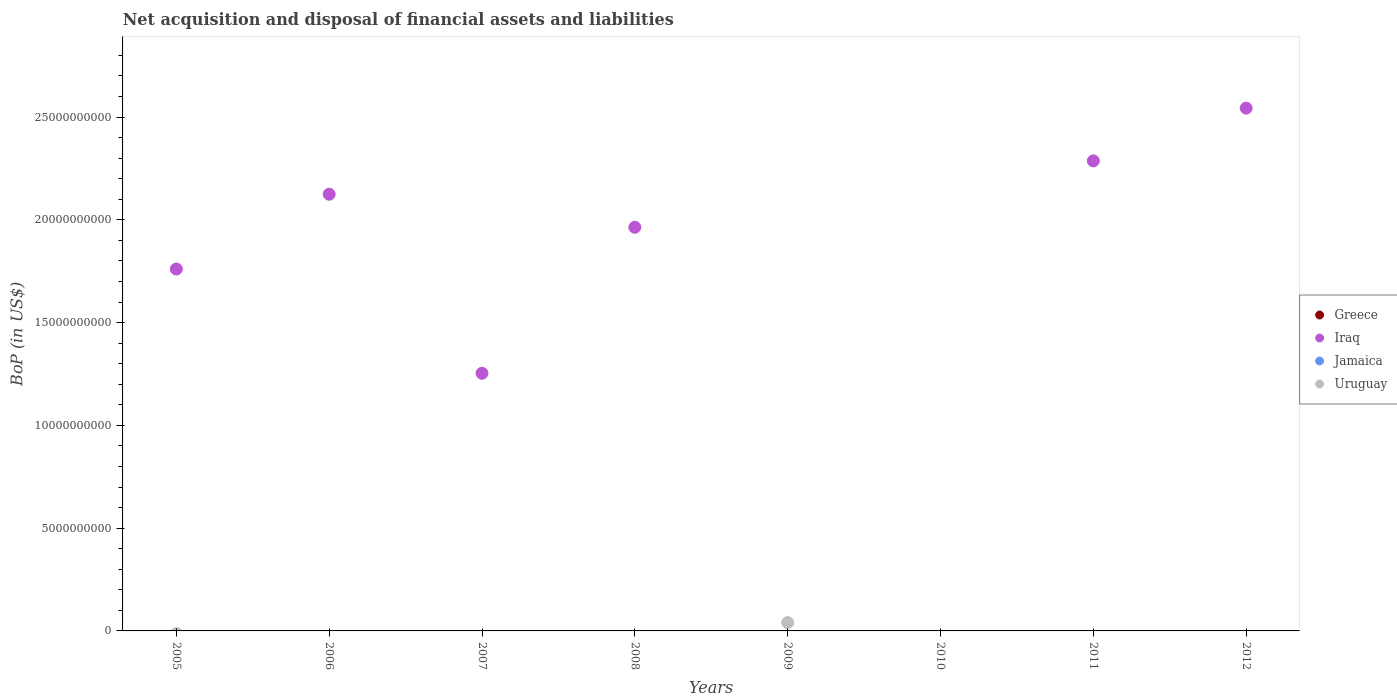How many different coloured dotlines are there?
Offer a very short reply. 2. Is the number of dotlines equal to the number of legend labels?
Offer a terse response. No. What is the Balance of Payments in Iraq in 2012?
Your response must be concise. 2.54e+1. Across all years, what is the maximum Balance of Payments in Iraq?
Offer a terse response. 2.54e+1. Across all years, what is the minimum Balance of Payments in Uruguay?
Your answer should be compact. 0. In which year was the Balance of Payments in Uruguay maximum?
Provide a succinct answer. 2009. What is the total Balance of Payments in Uruguay in the graph?
Your answer should be very brief. 4.04e+08. What is the difference between the Balance of Payments in Iraq in 2007 and that in 2008?
Ensure brevity in your answer.  -7.10e+09. What is the average Balance of Payments in Greece per year?
Your response must be concise. 0. In how many years, is the Balance of Payments in Jamaica greater than 24000000000 US$?
Offer a terse response. 0. What is the ratio of the Balance of Payments in Iraq in 2006 to that in 2008?
Provide a short and direct response. 1.08. What is the difference between the highest and the second highest Balance of Payments in Iraq?
Keep it short and to the point. 2.56e+09. What is the difference between the highest and the lowest Balance of Payments in Iraq?
Give a very brief answer. 2.54e+1. Is the sum of the Balance of Payments in Iraq in 2011 and 2012 greater than the maximum Balance of Payments in Uruguay across all years?
Give a very brief answer. Yes. Is it the case that in every year, the sum of the Balance of Payments in Jamaica and Balance of Payments in Iraq  is greater than the sum of Balance of Payments in Greece and Balance of Payments in Uruguay?
Provide a succinct answer. No. Is it the case that in every year, the sum of the Balance of Payments in Iraq and Balance of Payments in Greece  is greater than the Balance of Payments in Uruguay?
Provide a short and direct response. No. Does the Balance of Payments in Greece monotonically increase over the years?
Offer a very short reply. No. How many dotlines are there?
Offer a very short reply. 2. How many years are there in the graph?
Provide a succinct answer. 8. What is the difference between two consecutive major ticks on the Y-axis?
Keep it short and to the point. 5.00e+09. Does the graph contain any zero values?
Provide a short and direct response. Yes. Does the graph contain grids?
Ensure brevity in your answer.  No. Where does the legend appear in the graph?
Make the answer very short. Center right. How many legend labels are there?
Provide a short and direct response. 4. How are the legend labels stacked?
Your answer should be very brief. Vertical. What is the title of the graph?
Give a very brief answer. Net acquisition and disposal of financial assets and liabilities. Does "Somalia" appear as one of the legend labels in the graph?
Keep it short and to the point. No. What is the label or title of the Y-axis?
Offer a terse response. BoP (in US$). What is the BoP (in US$) of Iraq in 2005?
Your answer should be compact. 1.76e+1. What is the BoP (in US$) in Uruguay in 2005?
Offer a terse response. 0. What is the BoP (in US$) in Iraq in 2006?
Offer a terse response. 2.12e+1. What is the BoP (in US$) of Jamaica in 2006?
Your answer should be very brief. 0. What is the BoP (in US$) in Uruguay in 2006?
Make the answer very short. 0. What is the BoP (in US$) of Greece in 2007?
Give a very brief answer. 0. What is the BoP (in US$) of Iraq in 2007?
Offer a very short reply. 1.25e+1. What is the BoP (in US$) in Jamaica in 2007?
Offer a terse response. 0. What is the BoP (in US$) of Uruguay in 2007?
Offer a terse response. 0. What is the BoP (in US$) of Iraq in 2008?
Offer a very short reply. 1.96e+1. What is the BoP (in US$) of Iraq in 2009?
Your answer should be very brief. 0. What is the BoP (in US$) of Jamaica in 2009?
Your answer should be very brief. 0. What is the BoP (in US$) in Uruguay in 2009?
Provide a succinct answer. 4.04e+08. What is the BoP (in US$) in Uruguay in 2010?
Your answer should be compact. 0. What is the BoP (in US$) in Iraq in 2011?
Offer a very short reply. 2.29e+1. What is the BoP (in US$) of Jamaica in 2011?
Your answer should be compact. 0. What is the BoP (in US$) in Iraq in 2012?
Your answer should be compact. 2.54e+1. What is the BoP (in US$) in Uruguay in 2012?
Your answer should be very brief. 0. Across all years, what is the maximum BoP (in US$) in Iraq?
Your answer should be very brief. 2.54e+1. Across all years, what is the maximum BoP (in US$) of Uruguay?
Keep it short and to the point. 4.04e+08. Across all years, what is the minimum BoP (in US$) of Uruguay?
Provide a short and direct response. 0. What is the total BoP (in US$) of Greece in the graph?
Make the answer very short. 0. What is the total BoP (in US$) in Iraq in the graph?
Your answer should be compact. 1.19e+11. What is the total BoP (in US$) of Jamaica in the graph?
Offer a very short reply. 0. What is the total BoP (in US$) of Uruguay in the graph?
Provide a short and direct response. 4.04e+08. What is the difference between the BoP (in US$) of Iraq in 2005 and that in 2006?
Ensure brevity in your answer.  -3.64e+09. What is the difference between the BoP (in US$) of Iraq in 2005 and that in 2007?
Give a very brief answer. 5.07e+09. What is the difference between the BoP (in US$) of Iraq in 2005 and that in 2008?
Provide a short and direct response. -2.03e+09. What is the difference between the BoP (in US$) of Iraq in 2005 and that in 2011?
Give a very brief answer. -5.26e+09. What is the difference between the BoP (in US$) in Iraq in 2005 and that in 2012?
Offer a very short reply. -7.83e+09. What is the difference between the BoP (in US$) of Iraq in 2006 and that in 2007?
Give a very brief answer. 8.71e+09. What is the difference between the BoP (in US$) of Iraq in 2006 and that in 2008?
Provide a succinct answer. 1.61e+09. What is the difference between the BoP (in US$) in Iraq in 2006 and that in 2011?
Provide a succinct answer. -1.62e+09. What is the difference between the BoP (in US$) in Iraq in 2006 and that in 2012?
Provide a succinct answer. -4.19e+09. What is the difference between the BoP (in US$) of Iraq in 2007 and that in 2008?
Your response must be concise. -7.10e+09. What is the difference between the BoP (in US$) of Iraq in 2007 and that in 2011?
Offer a terse response. -1.03e+1. What is the difference between the BoP (in US$) of Iraq in 2007 and that in 2012?
Your response must be concise. -1.29e+1. What is the difference between the BoP (in US$) of Iraq in 2008 and that in 2011?
Offer a terse response. -3.23e+09. What is the difference between the BoP (in US$) of Iraq in 2008 and that in 2012?
Provide a short and direct response. -5.80e+09. What is the difference between the BoP (in US$) of Iraq in 2011 and that in 2012?
Your answer should be very brief. -2.56e+09. What is the difference between the BoP (in US$) in Iraq in 2005 and the BoP (in US$) in Uruguay in 2009?
Ensure brevity in your answer.  1.72e+1. What is the difference between the BoP (in US$) in Iraq in 2006 and the BoP (in US$) in Uruguay in 2009?
Your answer should be very brief. 2.08e+1. What is the difference between the BoP (in US$) in Iraq in 2007 and the BoP (in US$) in Uruguay in 2009?
Offer a terse response. 1.21e+1. What is the difference between the BoP (in US$) in Iraq in 2008 and the BoP (in US$) in Uruguay in 2009?
Give a very brief answer. 1.92e+1. What is the average BoP (in US$) in Iraq per year?
Offer a very short reply. 1.49e+1. What is the average BoP (in US$) in Jamaica per year?
Your answer should be very brief. 0. What is the average BoP (in US$) of Uruguay per year?
Offer a very short reply. 5.06e+07. What is the ratio of the BoP (in US$) in Iraq in 2005 to that in 2006?
Give a very brief answer. 0.83. What is the ratio of the BoP (in US$) of Iraq in 2005 to that in 2007?
Keep it short and to the point. 1.4. What is the ratio of the BoP (in US$) of Iraq in 2005 to that in 2008?
Keep it short and to the point. 0.9. What is the ratio of the BoP (in US$) of Iraq in 2005 to that in 2011?
Your response must be concise. 0.77. What is the ratio of the BoP (in US$) of Iraq in 2005 to that in 2012?
Your answer should be compact. 0.69. What is the ratio of the BoP (in US$) of Iraq in 2006 to that in 2007?
Provide a short and direct response. 1.69. What is the ratio of the BoP (in US$) of Iraq in 2006 to that in 2008?
Offer a very short reply. 1.08. What is the ratio of the BoP (in US$) in Iraq in 2006 to that in 2011?
Your answer should be compact. 0.93. What is the ratio of the BoP (in US$) in Iraq in 2006 to that in 2012?
Your answer should be compact. 0.84. What is the ratio of the BoP (in US$) in Iraq in 2007 to that in 2008?
Offer a terse response. 0.64. What is the ratio of the BoP (in US$) of Iraq in 2007 to that in 2011?
Keep it short and to the point. 0.55. What is the ratio of the BoP (in US$) in Iraq in 2007 to that in 2012?
Make the answer very short. 0.49. What is the ratio of the BoP (in US$) of Iraq in 2008 to that in 2011?
Give a very brief answer. 0.86. What is the ratio of the BoP (in US$) of Iraq in 2008 to that in 2012?
Your answer should be very brief. 0.77. What is the ratio of the BoP (in US$) of Iraq in 2011 to that in 2012?
Your response must be concise. 0.9. What is the difference between the highest and the second highest BoP (in US$) of Iraq?
Give a very brief answer. 2.56e+09. What is the difference between the highest and the lowest BoP (in US$) of Iraq?
Keep it short and to the point. 2.54e+1. What is the difference between the highest and the lowest BoP (in US$) in Uruguay?
Offer a terse response. 4.04e+08. 